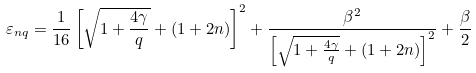Convert formula to latex. <formula><loc_0><loc_0><loc_500><loc_500>\varepsilon _ { n q } = \frac { 1 } { 1 6 } \left [ { \sqrt { 1 + \frac { 4 \gamma } { q } } + ( 1 + 2 n ) } \right ] ^ { 2 } + \frac { \beta ^ { 2 } } { \left [ { \sqrt { 1 + \frac { 4 \gamma } { q } } + ( 1 + 2 n ) } \right ] ^ { 2 } } + \frac { \beta } { 2 }</formula> 